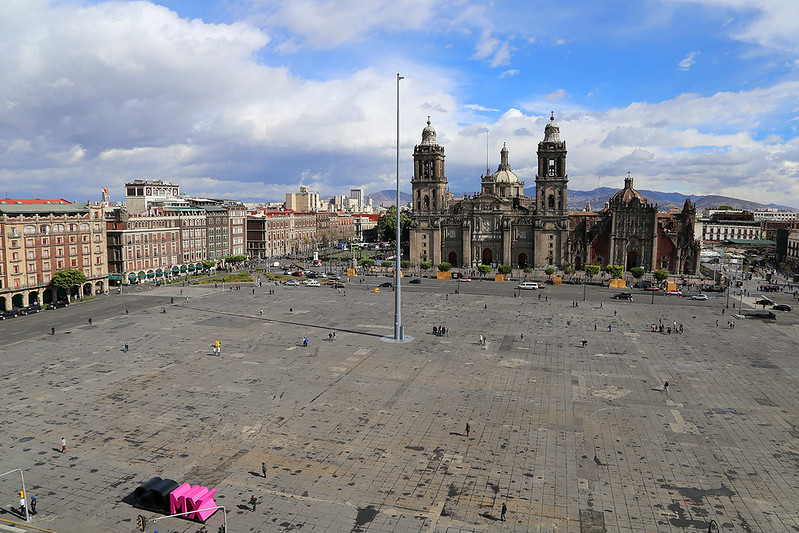Why does the square seem so empty? Is this typical? The emptiness of Zócalo in this image might not accurately reflect its usual state. Typically, this square is bustling with activity, brimming with tourists, and frequent cultural and political events. The apparent lack of crowd could be attributed to the time of day or perhaps a temporary situation. Occasionally, the square may be cleared for maintenance works or to set up large events, offering a rare view of its vast expanse. This moment of tranquility offers a unique perspective of the space, emphasizing its grand scale and the imposing nature of the surrounding architectural features. 